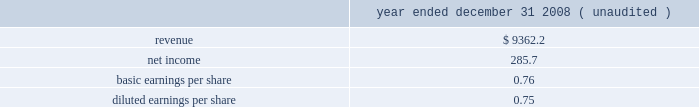Acquired is represented by allied 2019s infrastructure of market-based collection routes and its related integrated waste transfer and disposal channels , whose value has been included in goodwill .
All of the goodwill and other intangible assets resulting from the allied acquisition are not deductible for income tax purposes .
Pro forma information the consolidated financial statements presented for republic include the operating results of allied from december 5 , 2008 , the date of the acquisition .
The following pro forma information is presented assuming the acquisition had been completed as of january 1 , 2008 .
The unaudited pro forma information presented has been prepared for illustrative purposes and is not intended to be indicative of the results of operations that would have actually occurred had the acquisition been consummated at the beginning of the periods presented or of future results of the combined operations .
Furthermore , the pro forma results do not give effect to all cost savings or incremental costs that occur as a result of the integration and consolidation of the acquisition ( in millions , except share and per share amounts ) .
Year ended december 31 , ( unaudited ) .
The unaudited pro forma financial information includes adjustments for amortization of identifiable intangible assets , accretion of discounts to fair value associated with debt , environmental , self-insurance and other liabilities , accretion of capping , closure and post-closure obligations and amortization of the related assets , and provision for income taxes .
Restructuring charges as a result of the 2008 allied acquisition , we committed to a restructuring plan related to our corporate overhead and other administrative and operating functions .
The plan included closing our corporate office in florida , consolidating administrative functions to arizona , the former headquarters of allied , and reducing staffing levels .
The plan also included closing and consolidating certain operating locations and terminating certain leases .
During the years ended december 31 , 2010 and 2009 , we incurred $ 11.4 million , net of adjustments , and $ 63.2 million , respectively , of restructuring and integration charges related to our integration of allied .
These charges and adjustments primarily related to severance and other employee termination and relocation benefits and consulting and professional fees .
Substantially all the charges are recorded in our corporate segment .
We do not expect to incur additional charges to complete our plan .
We expect that the remaining charges will be paid during 2011 .
Republic services , inc .
Notes to consolidated financial statements , continued .
For the year ended december 31 2008 what was the net profit margin? 
Rationale: net profit margin is the ratio of the net income to the revenues
Computations: (285.7 / 9362.2)
Answer: 0.03052. 